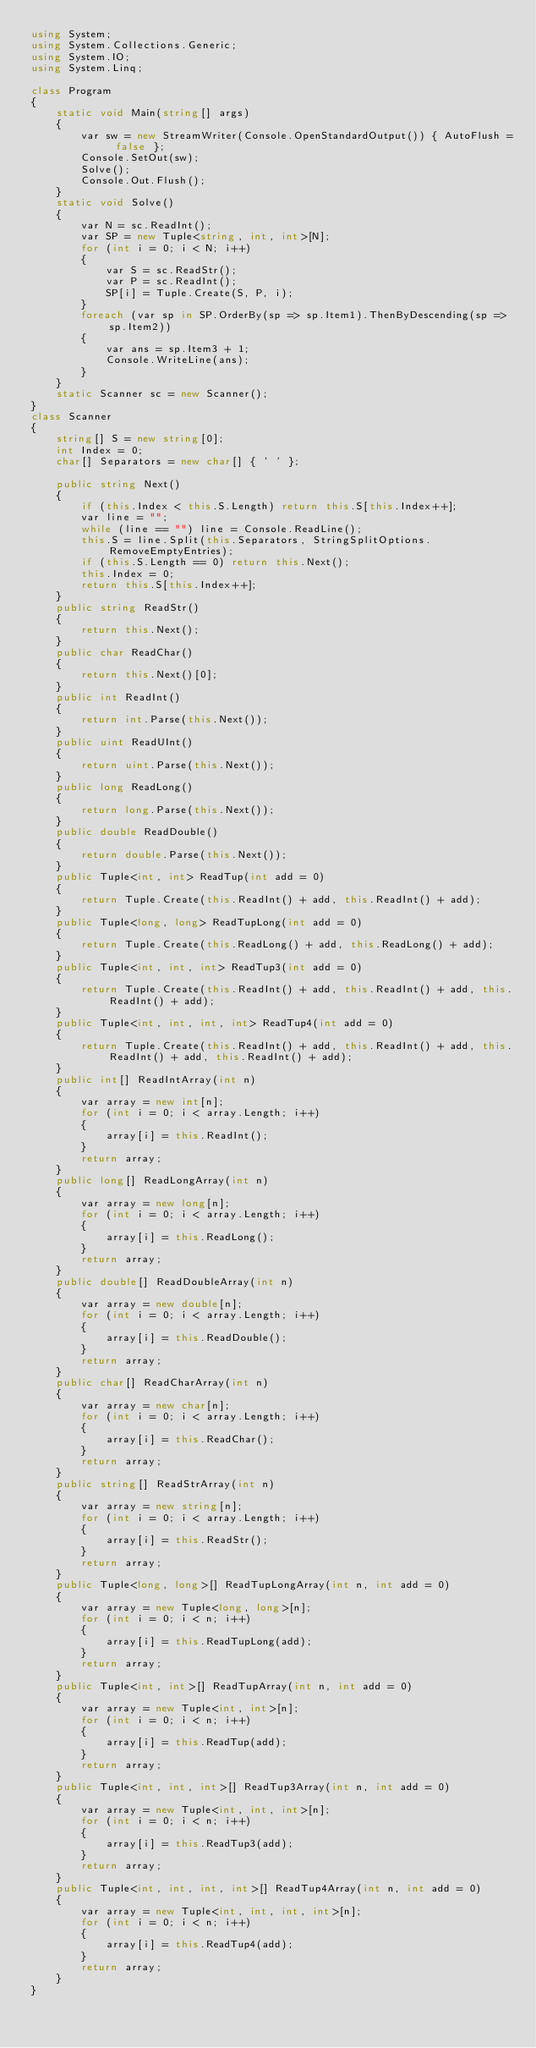Convert code to text. <code><loc_0><loc_0><loc_500><loc_500><_C#_>using System;
using System.Collections.Generic;
using System.IO;
using System.Linq;

class Program
{
    static void Main(string[] args)
    {
        var sw = new StreamWriter(Console.OpenStandardOutput()) { AutoFlush = false };
        Console.SetOut(sw);
        Solve();
        Console.Out.Flush();
    }
    static void Solve()
    {
        var N = sc.ReadInt();
        var SP = new Tuple<string, int, int>[N];
        for (int i = 0; i < N; i++)
        {
            var S = sc.ReadStr();
            var P = sc.ReadInt();
            SP[i] = Tuple.Create(S, P, i);
        }
        foreach (var sp in SP.OrderBy(sp => sp.Item1).ThenByDescending(sp => sp.Item2))
        {
            var ans = sp.Item3 + 1;
            Console.WriteLine(ans);
        }
    }
    static Scanner sc = new Scanner();
}
class Scanner
{
    string[] S = new string[0];
    int Index = 0;
    char[] Separators = new char[] { ' ' };

    public string Next()
    {
        if (this.Index < this.S.Length) return this.S[this.Index++];
        var line = "";
        while (line == "") line = Console.ReadLine();
        this.S = line.Split(this.Separators, StringSplitOptions.RemoveEmptyEntries);
        if (this.S.Length == 0) return this.Next();
        this.Index = 0;
        return this.S[this.Index++];
    }
    public string ReadStr()
    {
        return this.Next();
    }
    public char ReadChar()
    {
        return this.Next()[0];
    }
    public int ReadInt()
    {
        return int.Parse(this.Next());
    }
    public uint ReadUInt()
    {
        return uint.Parse(this.Next());
    }
    public long ReadLong()
    {
        return long.Parse(this.Next());
    }
    public double ReadDouble()
    {
        return double.Parse(this.Next());
    }
    public Tuple<int, int> ReadTup(int add = 0)
    {
        return Tuple.Create(this.ReadInt() + add, this.ReadInt() + add);
    }
    public Tuple<long, long> ReadTupLong(int add = 0)
    {
        return Tuple.Create(this.ReadLong() + add, this.ReadLong() + add);
    }
    public Tuple<int, int, int> ReadTup3(int add = 0)
    {
        return Tuple.Create(this.ReadInt() + add, this.ReadInt() + add, this.ReadInt() + add);
    }
    public Tuple<int, int, int, int> ReadTup4(int add = 0)
    {
        return Tuple.Create(this.ReadInt() + add, this.ReadInt() + add, this.ReadInt() + add, this.ReadInt() + add);
    }
    public int[] ReadIntArray(int n)
    {
        var array = new int[n];
        for (int i = 0; i < array.Length; i++)
        {
            array[i] = this.ReadInt();
        }
        return array;
    }
    public long[] ReadLongArray(int n)
    {
        var array = new long[n];
        for (int i = 0; i < array.Length; i++)
        {
            array[i] = this.ReadLong();
        }
        return array;
    }
    public double[] ReadDoubleArray(int n)
    {
        var array = new double[n];
        for (int i = 0; i < array.Length; i++)
        {
            array[i] = this.ReadDouble();
        }
        return array;
    }
    public char[] ReadCharArray(int n)
    {
        var array = new char[n];
        for (int i = 0; i < array.Length; i++)
        {
            array[i] = this.ReadChar();
        }
        return array;
    }
    public string[] ReadStrArray(int n)
    {
        var array = new string[n];
        for (int i = 0; i < array.Length; i++)
        {
            array[i] = this.ReadStr();
        }
        return array;
    }
    public Tuple<long, long>[] ReadTupLongArray(int n, int add = 0)
    {
        var array = new Tuple<long, long>[n];
        for (int i = 0; i < n; i++)
        {
            array[i] = this.ReadTupLong(add);
        }
        return array;
    }
    public Tuple<int, int>[] ReadTupArray(int n, int add = 0)
    {
        var array = new Tuple<int, int>[n];
        for (int i = 0; i < n; i++)
        {
            array[i] = this.ReadTup(add);
        }
        return array;
    }
    public Tuple<int, int, int>[] ReadTup3Array(int n, int add = 0)
    {
        var array = new Tuple<int, int, int>[n];
        for (int i = 0; i < n; i++)
        {
            array[i] = this.ReadTup3(add);
        }
        return array;
    }
    public Tuple<int, int, int, int>[] ReadTup4Array(int n, int add = 0)
    {
        var array = new Tuple<int, int, int, int>[n];
        for (int i = 0; i < n; i++)
        {
            array[i] = this.ReadTup4(add);
        }
        return array;
    }
}
</code> 